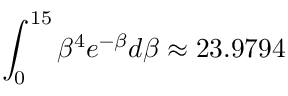Convert formula to latex. <formula><loc_0><loc_0><loc_500><loc_500>\int _ { 0 } ^ { 1 5 } { { \beta ^ { 4 } } { e ^ { - \beta } } d \beta \approx { 2 3 } { . 9 7 9 4 } }</formula> 